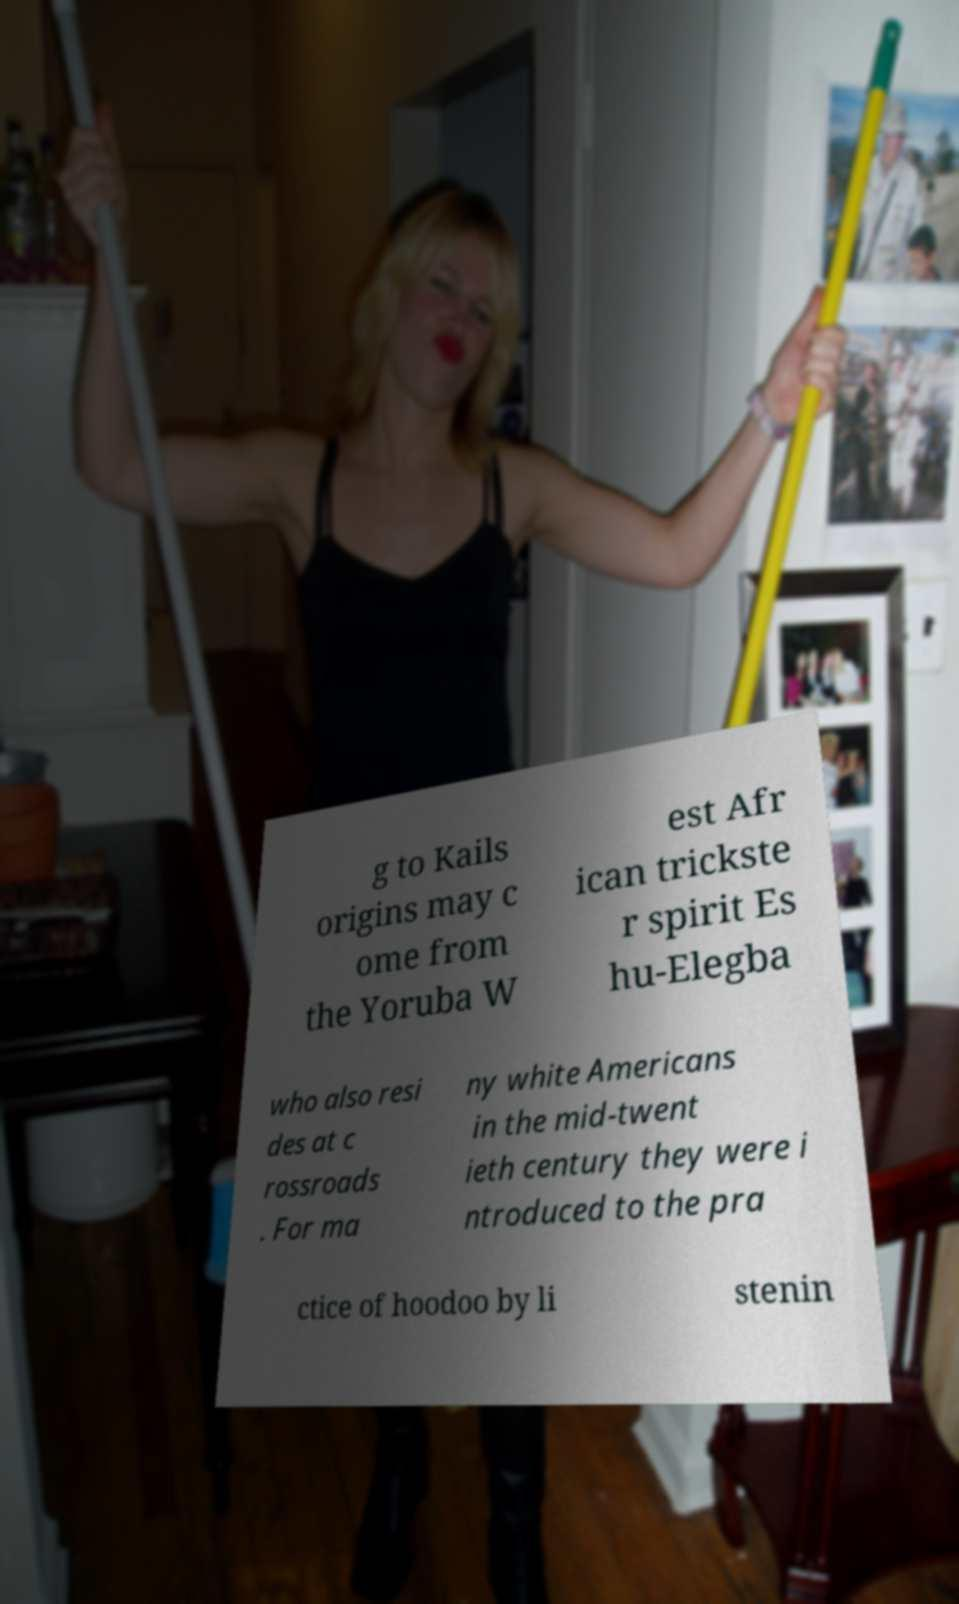Can you read and provide the text displayed in the image?This photo seems to have some interesting text. Can you extract and type it out for me? g to Kails origins may c ome from the Yoruba W est Afr ican trickste r spirit Es hu-Elegba who also resi des at c rossroads . For ma ny white Americans in the mid-twent ieth century they were i ntroduced to the pra ctice of hoodoo by li stenin 